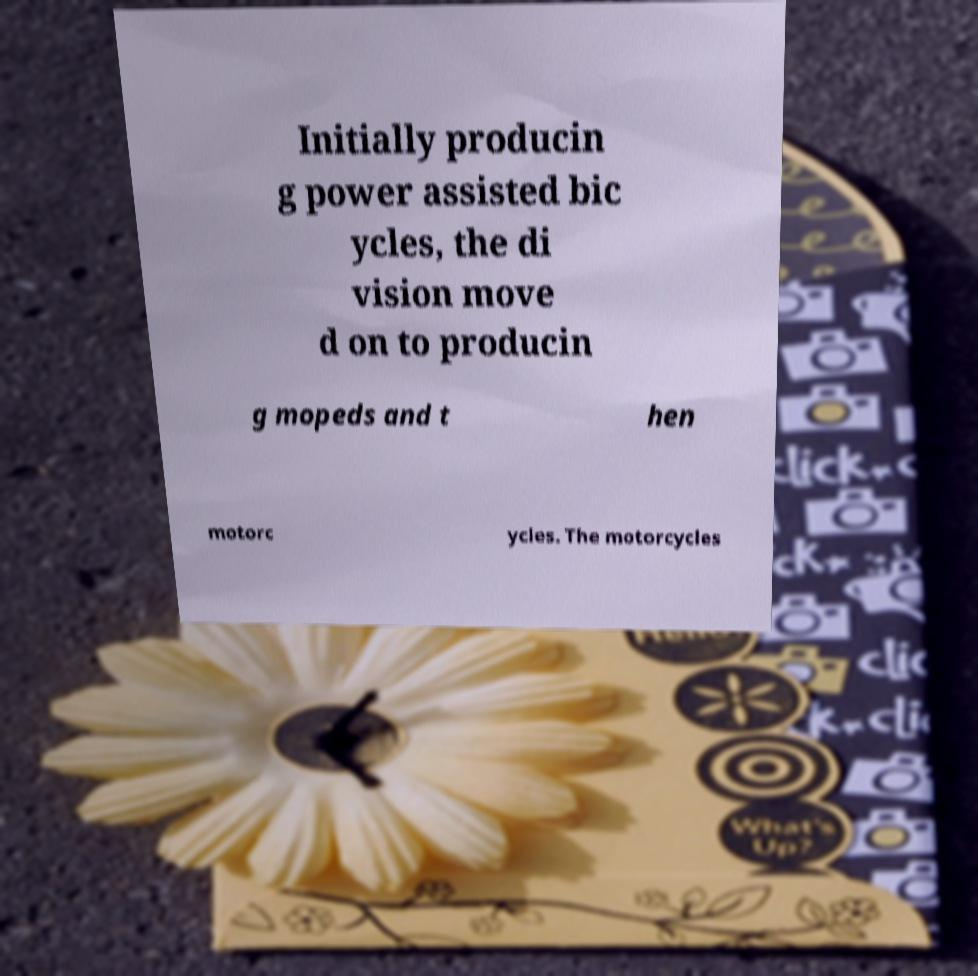What messages or text are displayed in this image? I need them in a readable, typed format. Initially producin g power assisted bic ycles, the di vision move d on to producin g mopeds and t hen motorc ycles. The motorcycles 